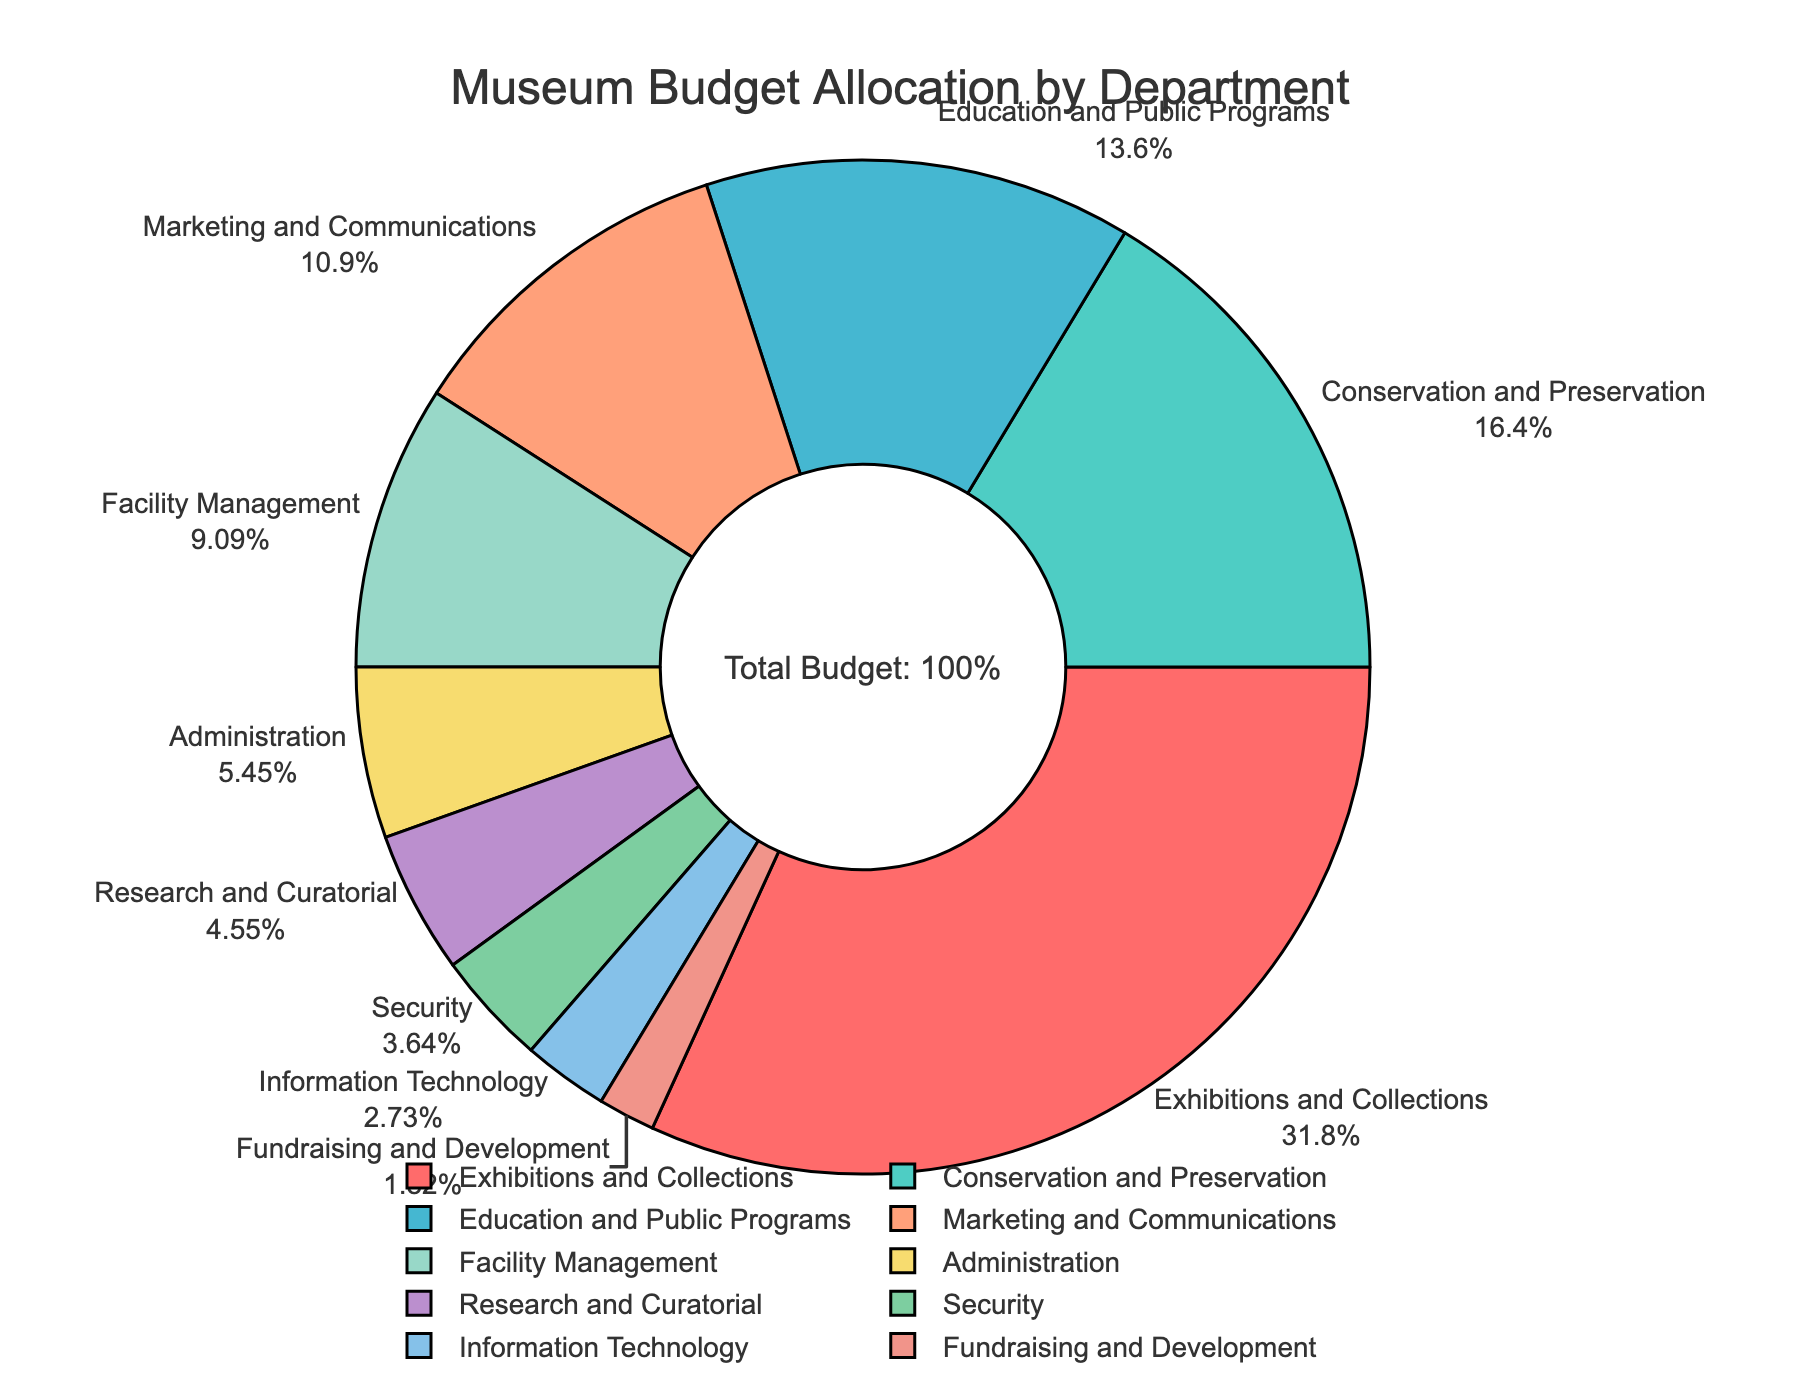Which department receives the largest portion of the budget? The "Exhibitions and Collections" department receives the largest portion of the budget at 35%. This can be directly seen from the pie chart as it shows the highest percentage.
Answer: Exhibitions and Collections Which departments have a budget allocation greater than 10%? By looking at the pie chart, the departments with budget allocations greater than 10% are:
1. Exhibitions and Collections (35%)
2. Conservation and Preservation (18%)
3. Education and Public Programs (15%)
4. Marketing and Communications (12%)
Answer: Exhibitions and Collections, Conservation and Preservation, Education and Public Programs, Marketing and Communications How much more budget allocation does the Conservation and Preservation department have compared to the Security department? The Conservation and Preservation department has 18% budget allocation, whereas the Security department has 4%. The difference is calculated as 18% - 4% = 14%.
Answer: 14% What is the combined budget allocation percentage for Facility Management, Administration, and Research and Curatorial departments? The Facility Management department has 10%, Administration has 6%, and Research and Curatorial has 5%. Adding these together: 10% + 6% + 5% = 21%.
Answer: 21% Is the budget allocation for Marketing and Communications higher or lower than Education and Public Programs? The budget allocation for Marketing and Communications is 12%, while for Education and Public Programs it is 15%. Therefore, Marketing and Communications is lower.
Answer: Lower Which department receives the smallest portion of the budget, and what is the percentage? By visually inspecting the pie chart, the Fundraising and Development department has the smallest portion at 2%.
Answer: Fundraising and Development, 2% How much total budget is allocated to Technical departments, namely Information Technology and Security? The Information Technology department has 3% and the Security department has 4%. Adding these together: 3% + 4% = 7%.
Answer: 7% What is the difference in budget allocation percentages between the department with the highest allocation and that with the lowest allocation? The department with the highest allocation is Exhibitions and Collections at 35%, and the lowest is Fundraising and Development at 2%. The difference is 35% - 2% = 33%.
Answer: 33% Which color is used to represent the Conservation and Preservation department in the pie chart? The Conservation and Preservation department is represented by a light green color in the pie chart. This observation is based on the custom color palette used in the pie chart and matching it visually with the chart.
Answer: Light green Among the departments receiving less than 10% of the budget allocation, which one receives the highest allocation? The departments receiving less than 10% are Administration (6%), Research and Curatorial (5%), Security (4%), Information Technology (3%), and Fundraising and Development (2%). Among these, Administration has the highest budget allocation at 6%.
Answer: Administration 